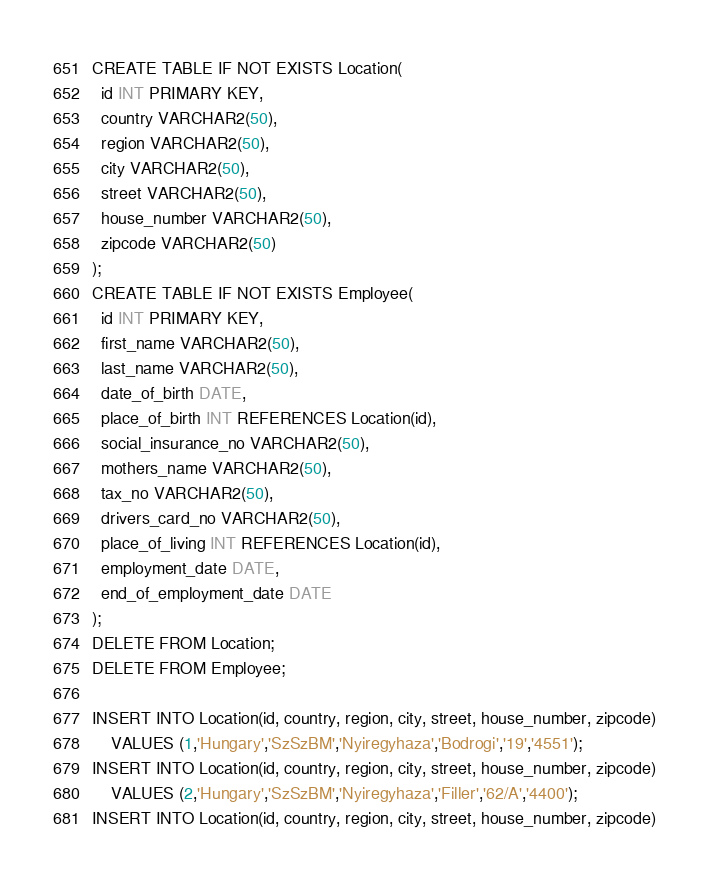<code> <loc_0><loc_0><loc_500><loc_500><_SQL_>CREATE TABLE IF NOT EXISTS Location(
  id INT PRIMARY KEY,
  country VARCHAR2(50),
  region VARCHAR2(50),
  city VARCHAR2(50),
  street VARCHAR2(50),
  house_number VARCHAR2(50),
  zipcode VARCHAR2(50)
);
CREATE TABLE IF NOT EXISTS Employee(
  id INT PRIMARY KEY,
  first_name VARCHAR2(50),
  last_name VARCHAR2(50),
  date_of_birth DATE,
  place_of_birth INT REFERENCES Location(id),
  social_insurance_no VARCHAR2(50),
  mothers_name VARCHAR2(50),
  tax_no VARCHAR2(50),
  drivers_card_no VARCHAR2(50),
  place_of_living INT REFERENCES Location(id),
  employment_date DATE,
  end_of_employment_date DATE
);
DELETE FROM Location;
DELETE FROM Employee;

INSERT INTO Location(id, country, region, city, street, house_number, zipcode)
    VALUES (1,'Hungary','SzSzBM','Nyiregyhaza','Bodrogi','19','4551');
INSERT INTO Location(id, country, region, city, street, house_number, zipcode)
    VALUES (2,'Hungary','SzSzBM','Nyiregyhaza','Filler','62/A','4400');
INSERT INTO Location(id, country, region, city, street, house_number, zipcode)</code> 